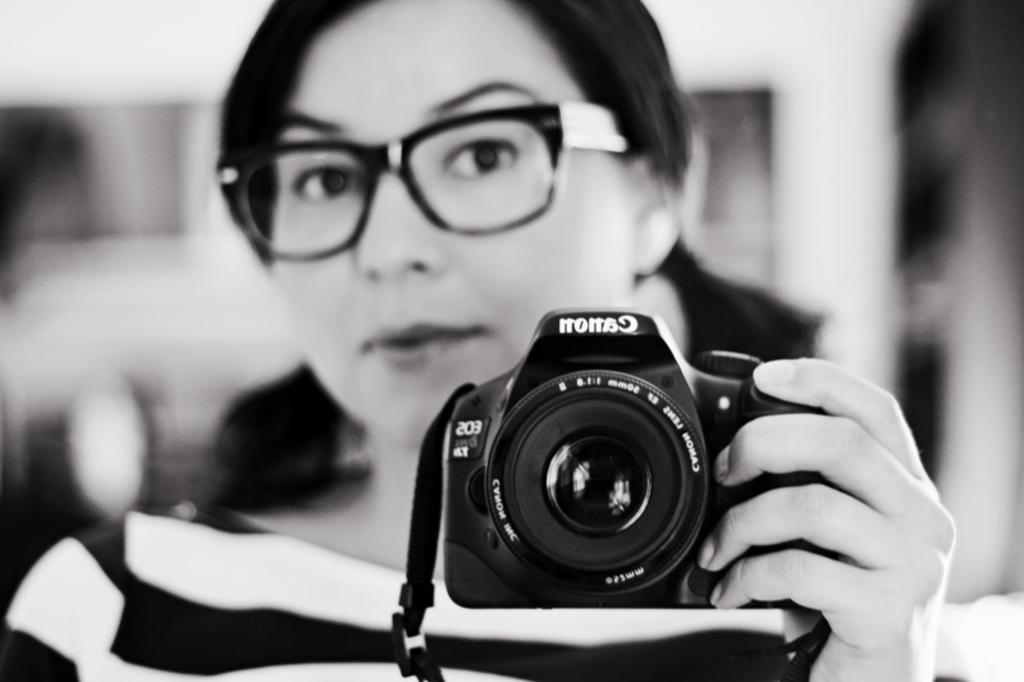Who is the main subject in the image? There is a lady in the image. What is the lady wearing? The lady is wearing a black and white shirt. Are there any accessories visible on the lady? Yes, the lady is wearing spectacles. What is the lady holding in the image? The lady is holding a camera. What is the lady doing with the camera? The lady is taking a picture in a mirror. Can you see any tigers in the image? No, there are no tigers present in the image. What is stopping the lady from taking a picture outside? The image does not provide information about the lady's intentions or the location, so it cannot be determined if she is trying to take a picture outside or if there is anything stopping her. 